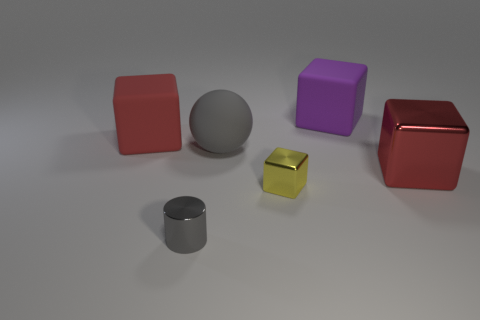Can you describe the lighting and shadows in the scene? The scene is lit from above, casting soft, diffuse shadows on the ground beneath each object. The intensity of the shadows varies, suggesting that the light source is not directly overhead but somewhat angled. 